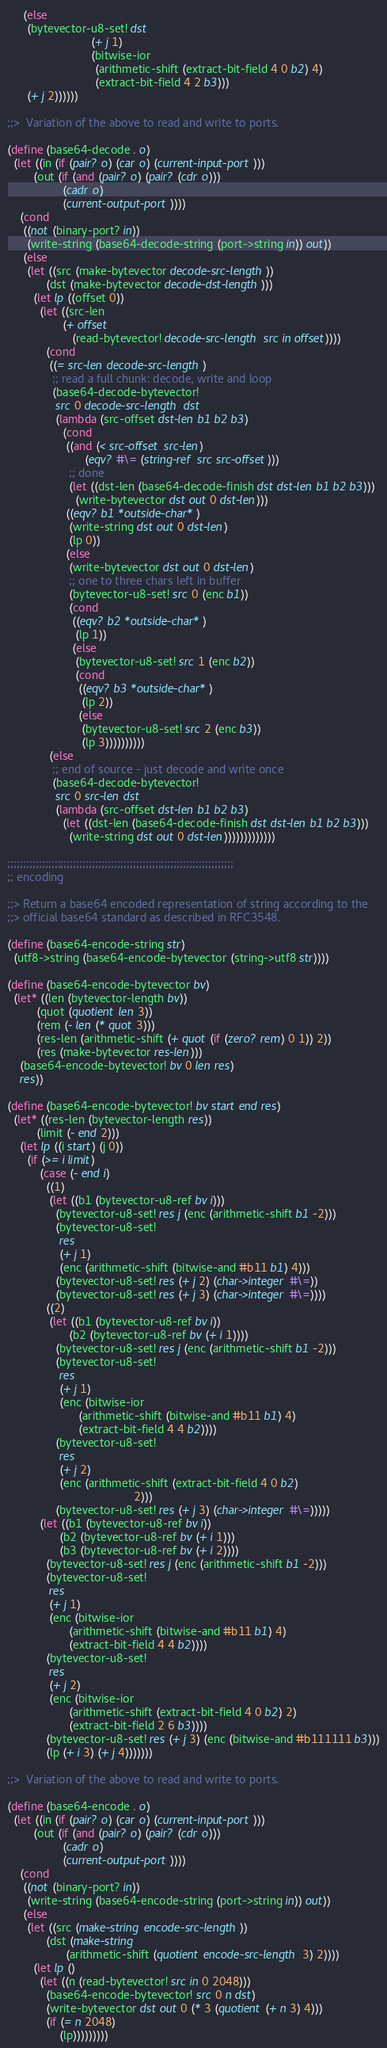Convert code to text. <code><loc_0><loc_0><loc_500><loc_500><_Scheme_>     (else
      (bytevector-u8-set! dst
                          (+ j 1)
                          (bitwise-ior
                           (arithmetic-shift (extract-bit-field 4 0 b2) 4)
                           (extract-bit-field 4 2 b3)))
      (+ j 2))))))

;;>  Variation of the above to read and write to ports.

(define (base64-decode . o)
  (let ((in (if (pair? o) (car o) (current-input-port)))
        (out (if (and (pair? o) (pair? (cdr o)))
                 (cadr o)
                 (current-output-port))))
    (cond
     ((not (binary-port? in))
      (write-string (base64-decode-string (port->string in)) out))
     (else
      (let ((src (make-bytevector decode-src-length))
            (dst (make-bytevector decode-dst-length)))
        (let lp ((offset 0))
          (let ((src-len
                 (+ offset
                    (read-bytevector! decode-src-length src in offset))))
            (cond
             ((= src-len decode-src-length)
              ;; read a full chunk: decode, write and loop
              (base64-decode-bytevector!
               src 0 decode-src-length dst
               (lambda (src-offset dst-len b1 b2 b3)
                 (cond
                  ((and (< src-offset src-len)
                        (eqv? #\= (string-ref src src-offset)))
                   ;; done
                   (let ((dst-len (base64-decode-finish dst dst-len b1 b2 b3)))
                     (write-bytevector dst out 0 dst-len)))
                  ((eqv? b1 *outside-char*)
                   (write-string dst out 0 dst-len)
                   (lp 0))
                  (else
                   (write-bytevector dst out 0 dst-len)
                   ;; one to three chars left in buffer
                   (bytevector-u8-set! src 0 (enc b1))
                   (cond
                    ((eqv? b2 *outside-char*)
                     (lp 1))
                    (else
                     (bytevector-u8-set! src 1 (enc b2))
                     (cond
                      ((eqv? b3 *outside-char*)
                       (lp 2))
                      (else
                       (bytevector-u8-set! src 2 (enc b3))
                       (lp 3))))))))))
             (else
              ;; end of source - just decode and write once
              (base64-decode-bytevector!
               src 0 src-len dst
               (lambda (src-offset dst-len b1 b2 b3)
                 (let ((dst-len (base64-decode-finish dst dst-len b1 b2 b3)))
                   (write-string dst out 0 dst-len)))))))))))))

;;;;;;;;;;;;;;;;;;;;;;;;;;;;;;;;;;;;;;;;;;;;;;;;;;;;;;;;;;;;;;;;;;;;;;;;
;; encoding

;;> Return a base64 encoded representation of string according to the
;;> official base64 standard as described in RFC3548.

(define (base64-encode-string str)
  (utf8->string (base64-encode-bytevector (string->utf8 str))))

(define (base64-encode-bytevector bv)
  (let* ((len (bytevector-length bv))
         (quot (quotient len 3))
         (rem (- len (* quot 3)))
         (res-len (arithmetic-shift (+ quot (if (zero? rem) 0 1)) 2))
         (res (make-bytevector res-len)))
    (base64-encode-bytevector! bv 0 len res)
    res))

(define (base64-encode-bytevector! bv start end res)
  (let* ((res-len (bytevector-length res))
         (limit (- end 2)))
    (let lp ((i start) (j 0))
      (if (>= i limit)
          (case (- end i)
            ((1)
             (let ((b1 (bytevector-u8-ref bv i)))
               (bytevector-u8-set! res j (enc (arithmetic-shift b1 -2)))
               (bytevector-u8-set!
                res
                (+ j 1)
                (enc (arithmetic-shift (bitwise-and #b11 b1) 4)))
               (bytevector-u8-set! res (+ j 2) (char->integer #\=))
               (bytevector-u8-set! res (+ j 3) (char->integer #\=))))
            ((2)
             (let ((b1 (bytevector-u8-ref bv i))
                   (b2 (bytevector-u8-ref bv (+ i 1))))
               (bytevector-u8-set! res j (enc (arithmetic-shift b1 -2)))
               (bytevector-u8-set!
                res
                (+ j 1)
                (enc (bitwise-ior
                      (arithmetic-shift (bitwise-and #b11 b1) 4)
                      (extract-bit-field 4 4 b2))))
               (bytevector-u8-set!
                res
                (+ j 2)
                (enc (arithmetic-shift (extract-bit-field 4 0 b2)
                                       2)))
               (bytevector-u8-set! res (+ j 3) (char->integer #\=)))))
          (let ((b1 (bytevector-u8-ref bv i))
                (b2 (bytevector-u8-ref bv (+ i 1)))
                (b3 (bytevector-u8-ref bv (+ i 2))))
            (bytevector-u8-set! res j (enc (arithmetic-shift b1 -2)))
            (bytevector-u8-set!
             res
             (+ j 1)
             (enc (bitwise-ior
                   (arithmetic-shift (bitwise-and #b11 b1) 4)
                   (extract-bit-field 4 4 b2))))
            (bytevector-u8-set!
             res
             (+ j 2)
             (enc (bitwise-ior
                   (arithmetic-shift (extract-bit-field 4 0 b2) 2)
                   (extract-bit-field 2 6 b3))))
            (bytevector-u8-set! res (+ j 3) (enc (bitwise-and #b111111 b3)))
            (lp (+ i 3) (+ j 4)))))))

;;>  Variation of the above to read and write to ports.

(define (base64-encode . o)
  (let ((in (if (pair? o) (car o) (current-input-port)))
        (out (if (and (pair? o) (pair? (cdr o)))
                 (cadr o)
                 (current-output-port))))
    (cond
     ((not (binary-port? in))
      (write-string (base64-encode-string (port->string in)) out))
     (else
      (let ((src (make-string encode-src-length))
            (dst (make-string
                  (arithmetic-shift (quotient encode-src-length 3) 2))))
        (let lp ()
          (let ((n (read-bytevector! src in 0 2048)))
            (base64-encode-bytevector! src 0 n dst)
            (write-bytevector dst out 0 (* 3 (quotient (+ n 3) 4)))
            (if (= n 2048)
                (lp)))))))))
</code> 